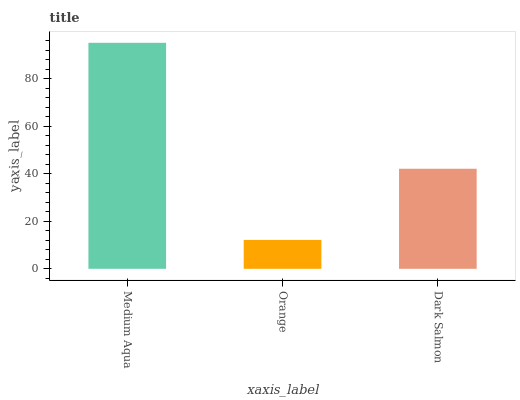Is Orange the minimum?
Answer yes or no. Yes. Is Medium Aqua the maximum?
Answer yes or no. Yes. Is Dark Salmon the minimum?
Answer yes or no. No. Is Dark Salmon the maximum?
Answer yes or no. No. Is Dark Salmon greater than Orange?
Answer yes or no. Yes. Is Orange less than Dark Salmon?
Answer yes or no. Yes. Is Orange greater than Dark Salmon?
Answer yes or no. No. Is Dark Salmon less than Orange?
Answer yes or no. No. Is Dark Salmon the high median?
Answer yes or no. Yes. Is Dark Salmon the low median?
Answer yes or no. Yes. Is Medium Aqua the high median?
Answer yes or no. No. Is Orange the low median?
Answer yes or no. No. 